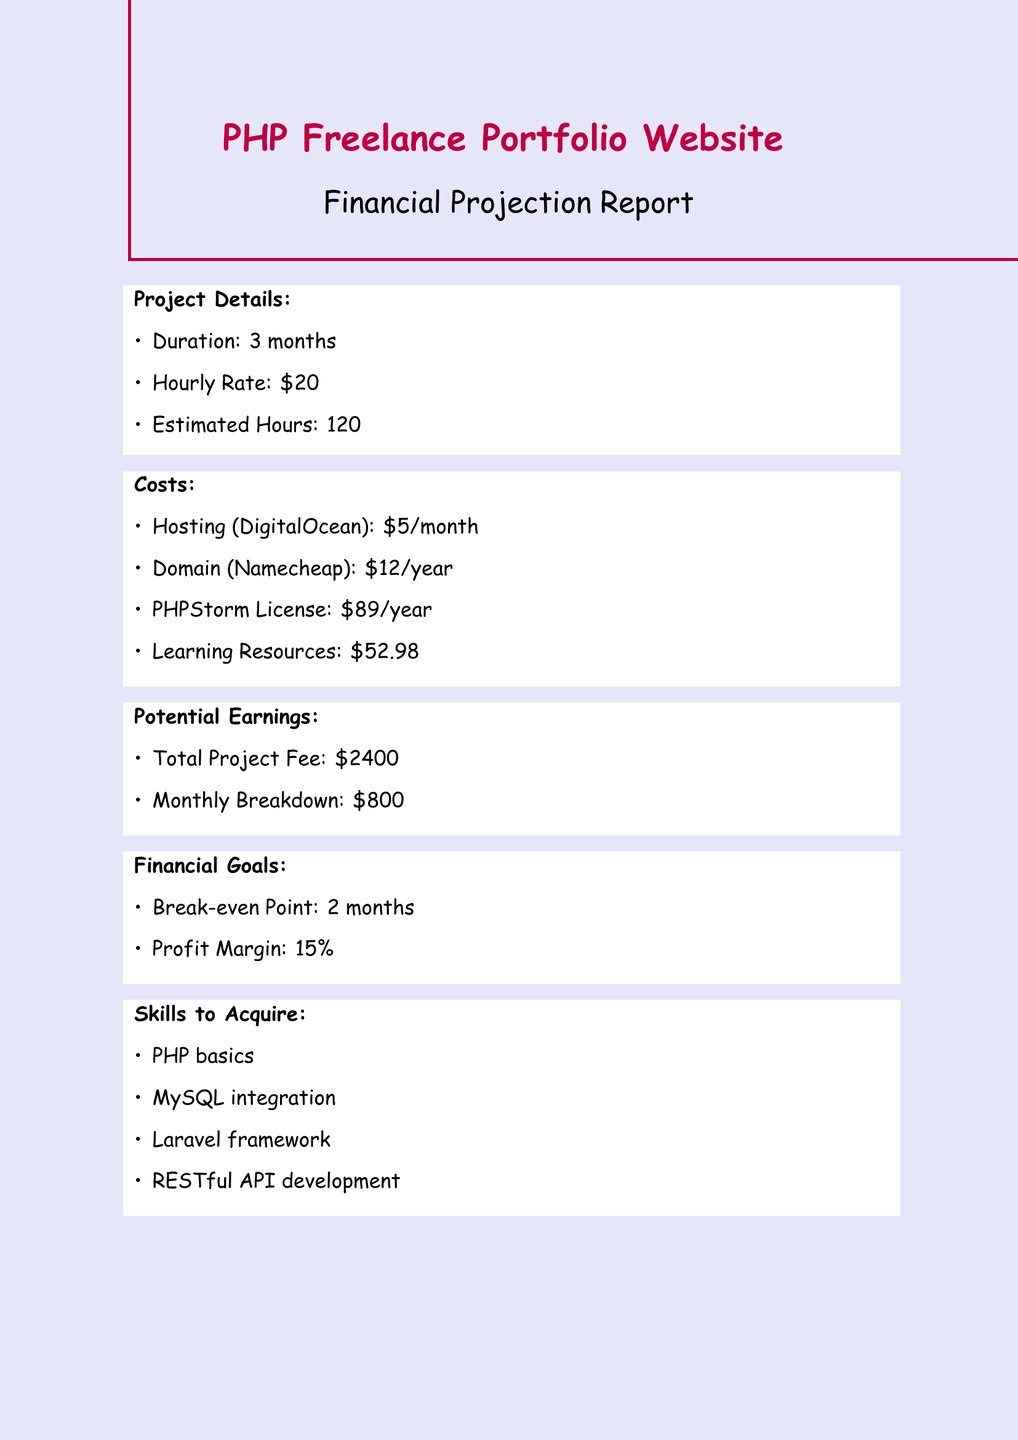What is the project duration? The document states the duration of the project is three months.
Answer: 3 months What is the hourly rate? The document specifies the hourly rate is twenty dollars.
Answer: $20 What are the total costs for learning resources? The document lists the learning resource costs and their total amounts to fifty-two dollars and ninety-eight cents.
Answer: $52.98 What is the total project fee? The total project fee is mentioned in the potential earnings section as two thousand four hundred dollars.
Answer: $2400 How many estimated hours will be worked on this project? The document indicates that the estimated hours for the project are one hundred twenty.
Answer: 120 What is the break-even point? The break-even point is mentioned in the financial goals section, which is two months.
Answer: 2 months How much daily coding practice is planned? The self-doubt mitigation plan specifies that two hours of daily coding practice will be undertaken.
Answer: 2 hours What is the profit margin goal? The profit margin goal is stated in the financial goals section as fifteen percent.
Answer: 15% Which online community is suggested for joining? The self-doubt mitigation section recommends joining the PHP Developers Forum.
Answer: PHP Developers Forum 